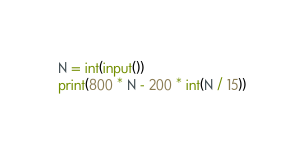Convert code to text. <code><loc_0><loc_0><loc_500><loc_500><_Python_>N = int(input())
print(800 * N - 200 * int(N / 15))
</code> 